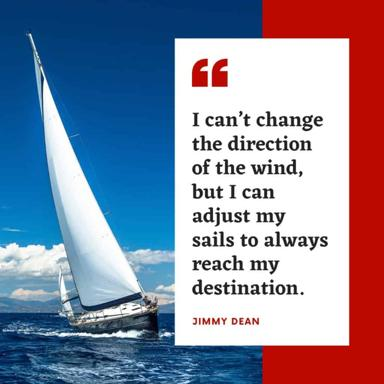What feelings does the image evoke through its use of color and composition? The image evokes a sense of determination and calm. The deep blues of the water and sky convey tranquility, while the white sail stands out as a symbol of purity and focus. The striking red frame adds an element of intensity, perhaps highlighting the importance of passion and action in reaching one’s goals. 